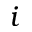<formula> <loc_0><loc_0><loc_500><loc_500>i</formula> 